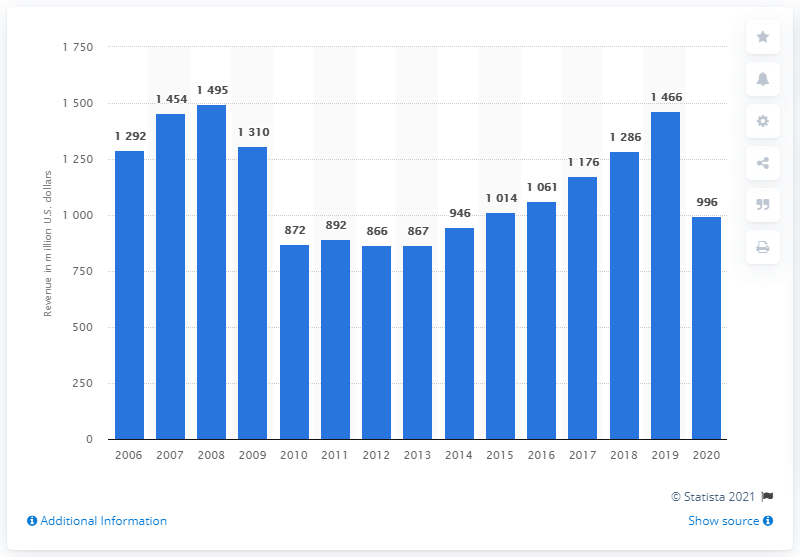Specify some key components in this picture. In 2020, Pulmicort's revenue was approximately 996 million dollars. 